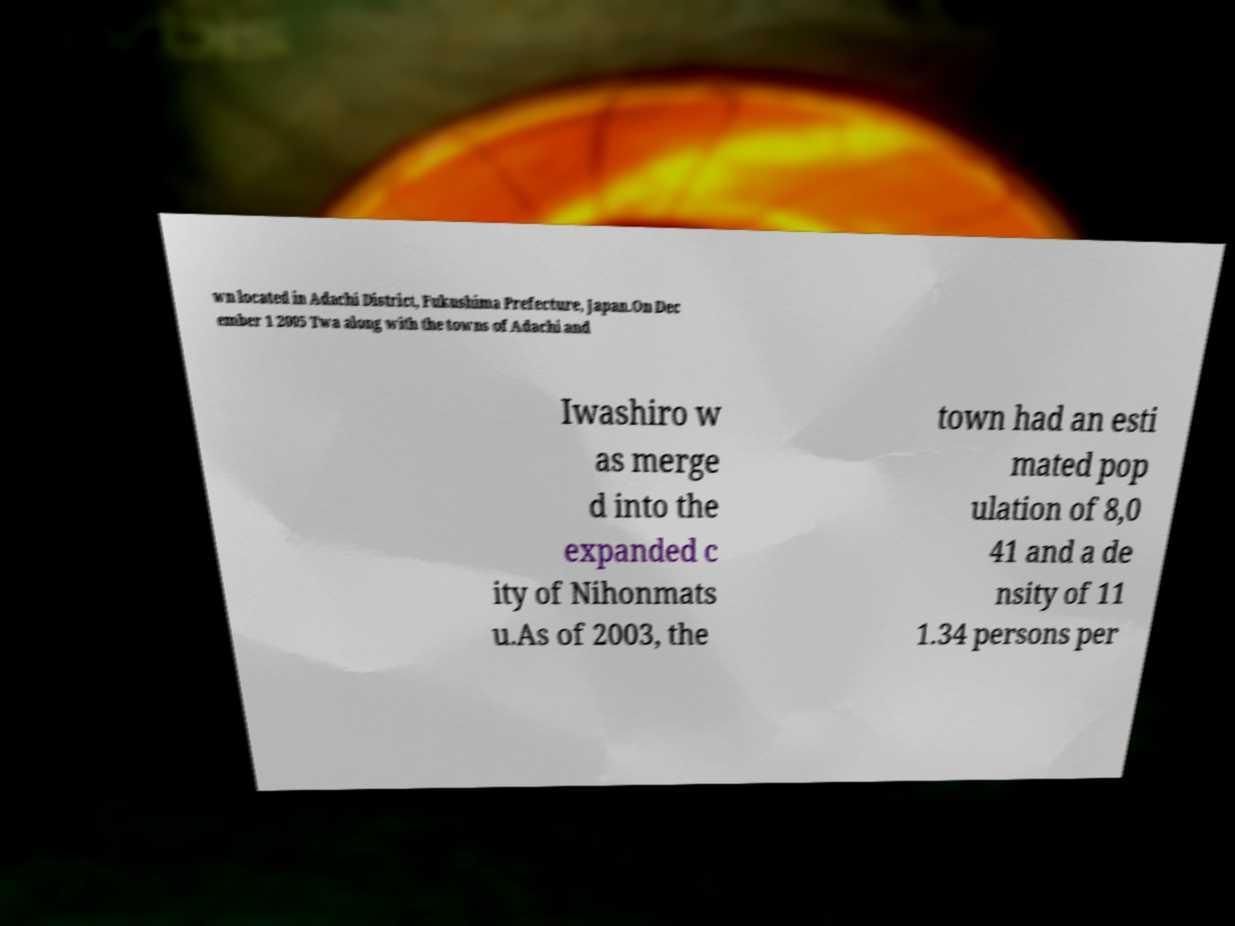I need the written content from this picture converted into text. Can you do that? wn located in Adachi District, Fukushima Prefecture, Japan.On Dec ember 1 2005 Twa along with the towns of Adachi and Iwashiro w as merge d into the expanded c ity of Nihonmats u.As of 2003, the town had an esti mated pop ulation of 8,0 41 and a de nsity of 11 1.34 persons per 